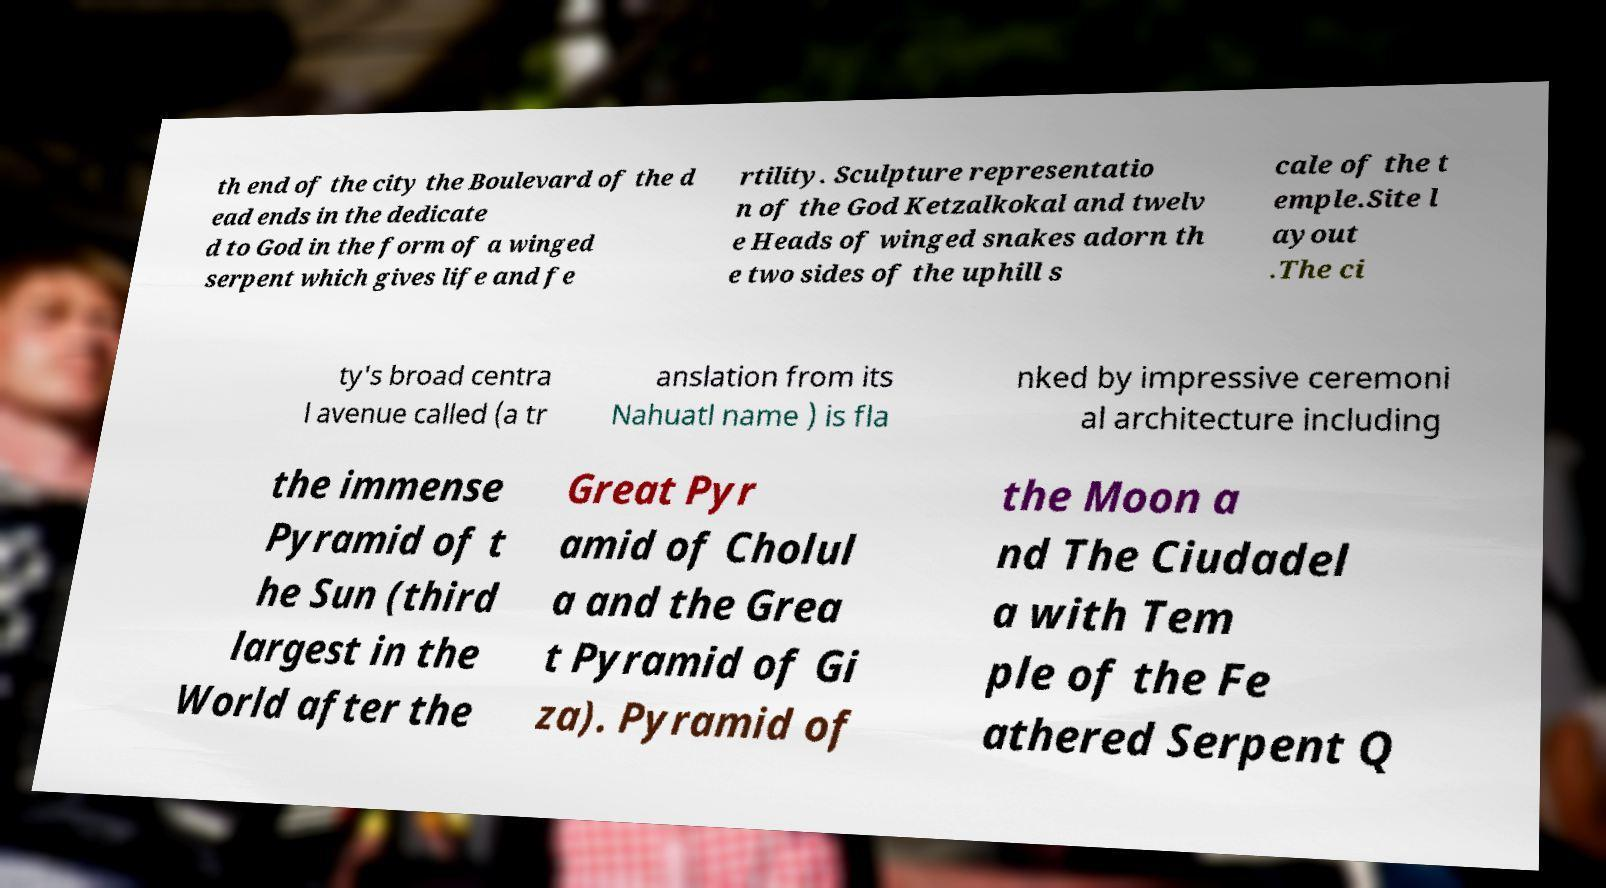Please identify and transcribe the text found in this image. th end of the city the Boulevard of the d ead ends in the dedicate d to God in the form of a winged serpent which gives life and fe rtility. Sculpture representatio n of the God Ketzalkokal and twelv e Heads of winged snakes adorn th e two sides of the uphill s cale of the t emple.Site l ayout .The ci ty's broad centra l avenue called (a tr anslation from its Nahuatl name ) is fla nked by impressive ceremoni al architecture including the immense Pyramid of t he Sun (third largest in the World after the Great Pyr amid of Cholul a and the Grea t Pyramid of Gi za). Pyramid of the Moon a nd The Ciudadel a with Tem ple of the Fe athered Serpent Q 